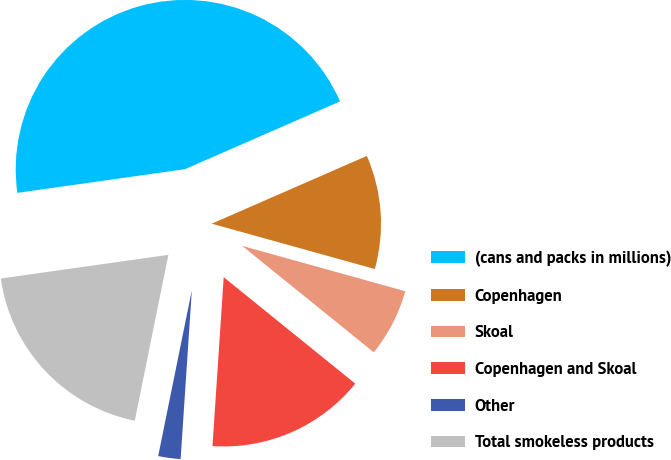Convert chart. <chart><loc_0><loc_0><loc_500><loc_500><pie_chart><fcel>(cans and packs in millions)<fcel>Copenhagen<fcel>Skoal<fcel>Copenhagen and Skoal<fcel>Other<fcel>Total smokeless products<nl><fcel>45.68%<fcel>10.87%<fcel>6.51%<fcel>15.23%<fcel>2.13%<fcel>19.58%<nl></chart> 